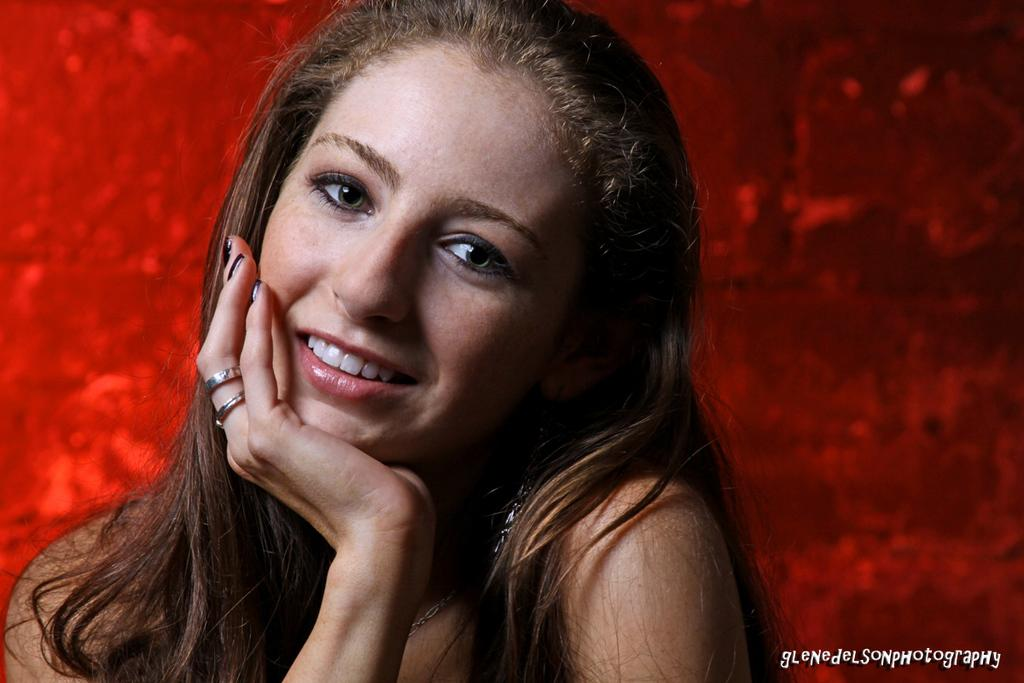Who is present in the image? There is a woman in the image. What is the woman's expression? The woman is smiling. What color is the background of the image? The background of the image is red. Where is the text located in the image? The text is in the bottom right side of the image. How many children are playing with bricks in the image? There are no children or bricks present in the image; it features a woman with a red background and text in the bottom right side. 